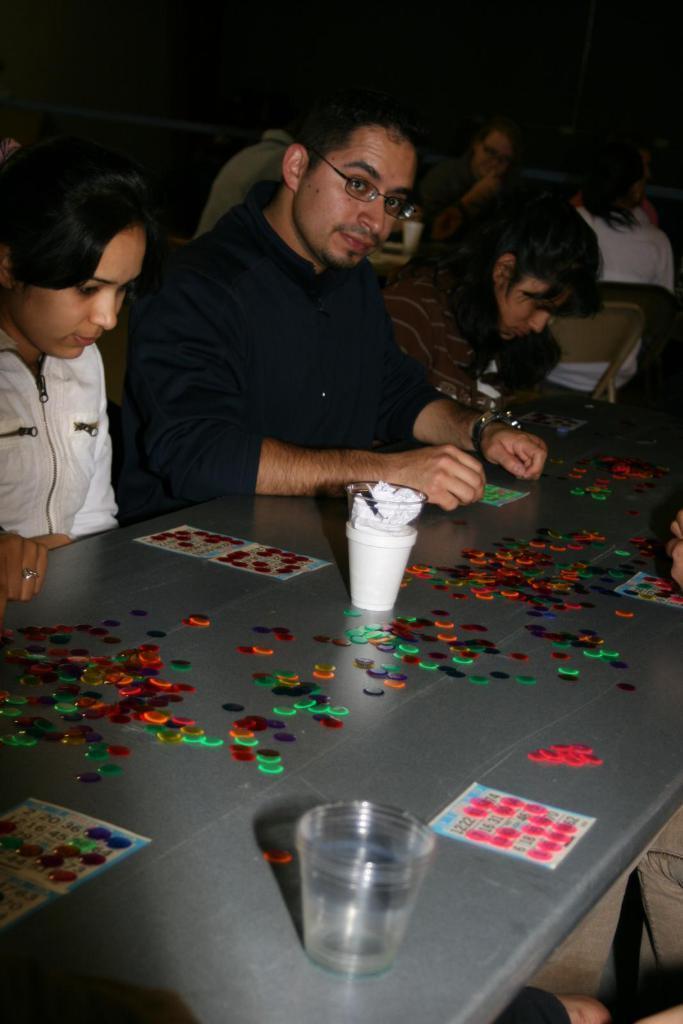Please provide a concise description of this image. Few persons are sitting on the chair. We can see glass,cup,bowl and things on the table. 